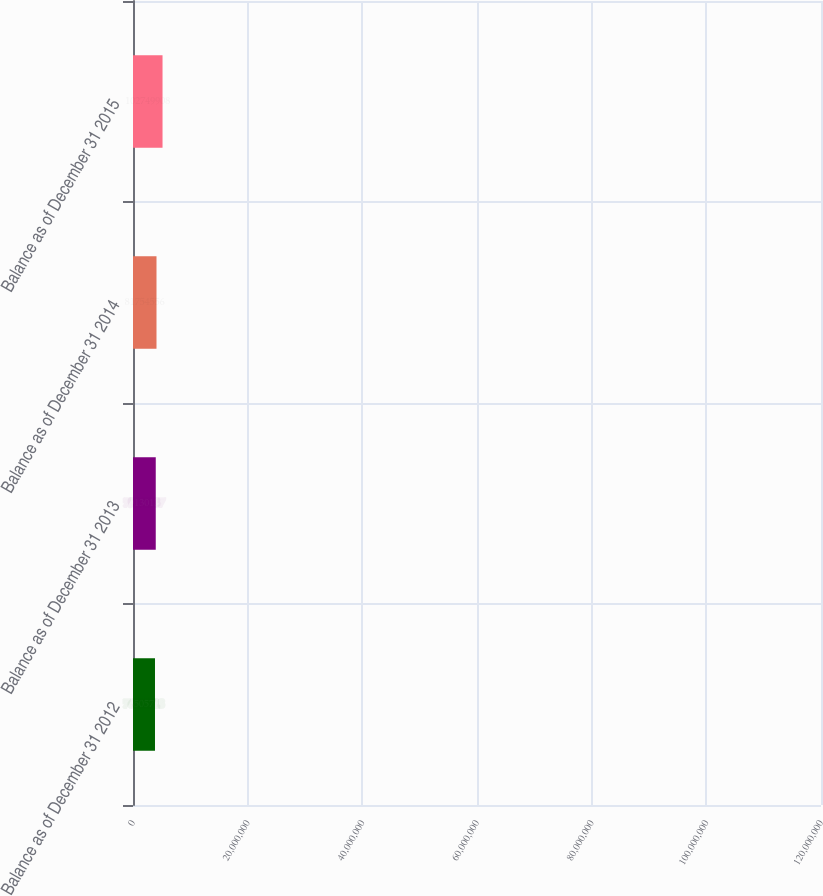Convert chart. <chart><loc_0><loc_0><loc_500><loc_500><bar_chart><fcel>Balance as of December 31 2012<fcel>Balance as of December 31 2013<fcel>Balance as of December 31 2014<fcel>Balance as of December 31 2015<nl><fcel>7.65057e+07<fcel>7.91301e+07<fcel>8.17546e+07<fcel>1.0275e+08<nl></chart> 